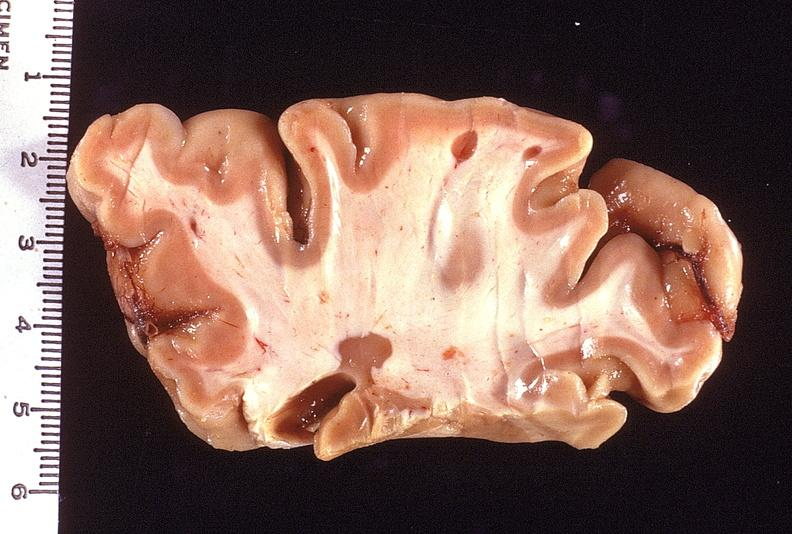does sickle cell disease show brain, multiple sclerosis?
Answer the question using a single word or phrase. No 